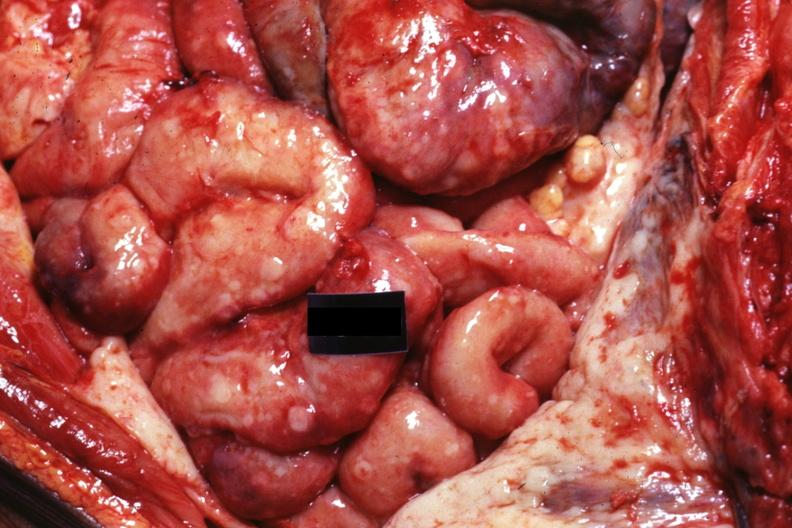what is present?
Answer the question using a single word or phrase. Peritoneum 